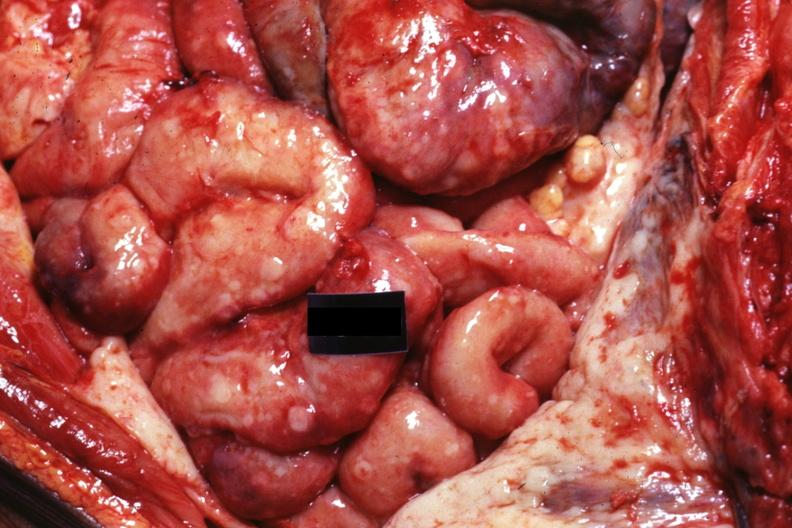what is present?
Answer the question using a single word or phrase. Peritoneum 